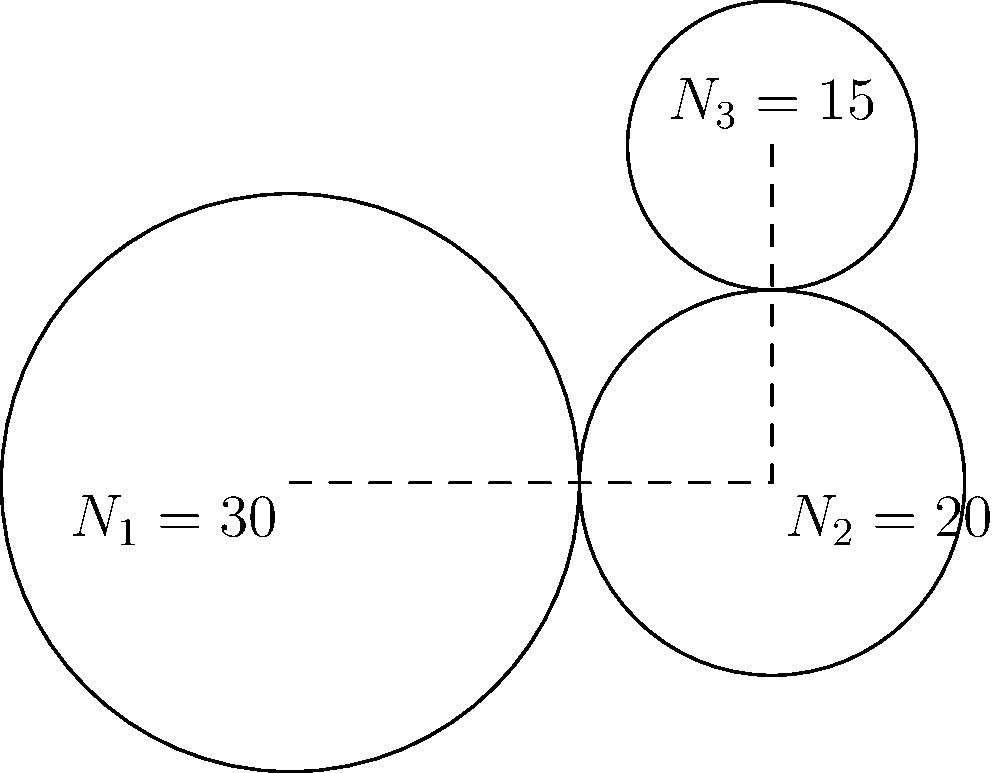In the simple gear train shown, gear 1 has 30 teeth, gear 2 has 20 teeth, and gear 3 has 15 teeth. If the input torque on gear 1 is 100 N⋅m, what is the output torque on gear 3? Assume no power loss in the system. To solve this problem, we need to follow these steps:

1. Calculate the overall gear ratio of the system:
   The gear ratio between two gears is the ratio of their number of teeth.
   $$\text{Gear ratio } (R) = \frac{\text{Number of teeth on driven gear}}{\text{Number of teeth on driving gear}}$$

   For gears 1 and 2: $R_{12} = \frac{N_2}{N_1} = \frac{20}{30} = \frac{2}{3}$
   For gears 2 and 3: $R_{23} = \frac{N_3}{N_2} = \frac{15}{20} = \frac{3}{4}$

   Overall gear ratio: $R_{\text{total}} = R_{12} \times R_{23} = \frac{2}{3} \times \frac{3}{4} = \frac{1}{2}$

2. Use the principle of torque multiplication:
   In a gear train, the ratio of output torque to input torque is inversely proportional to the gear ratio.
   $$\frac{T_{\text{out}}}{T_{\text{in}}} = \frac{1}{R_{\text{total}}}$$

3. Calculate the output torque:
   $$T_{\text{out}} = \frac{T_{\text{in}}}{R_{\text{total}}} = \frac{100 \text{ N⋅m}}{\frac{1}{2}} = 200 \text{ N⋅m}$$

Therefore, the output torque on gear 3 is 200 N⋅m.
Answer: 200 N⋅m 